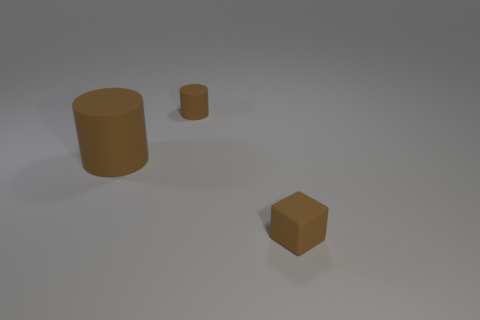The other rubber object that is the same shape as the large matte object is what size?
Make the answer very short. Small. How many big things are the same material as the small brown cylinder?
Make the answer very short. 1. How many objects are small brown blocks or brown objects?
Your response must be concise. 3. Is there a brown object that is to the right of the small thing that is behind the large brown rubber thing?
Make the answer very short. Yes. Is the number of brown blocks that are on the right side of the brown cube greater than the number of cylinders that are behind the tiny matte cylinder?
Keep it short and to the point. No. What number of objects are the same color as the big cylinder?
Your answer should be compact. 2. There is a tiny matte cylinder that is behind the brown matte cube; is its color the same as the big thing that is to the left of the brown rubber block?
Your answer should be compact. Yes. Are there any tiny brown rubber objects behind the brown rubber cube?
Your answer should be compact. Yes. The tiny brown object left of the tiny rubber cube has what shape?
Make the answer very short. Cylinder. There is a matte block that is the same color as the large object; what size is it?
Offer a very short reply. Small. 